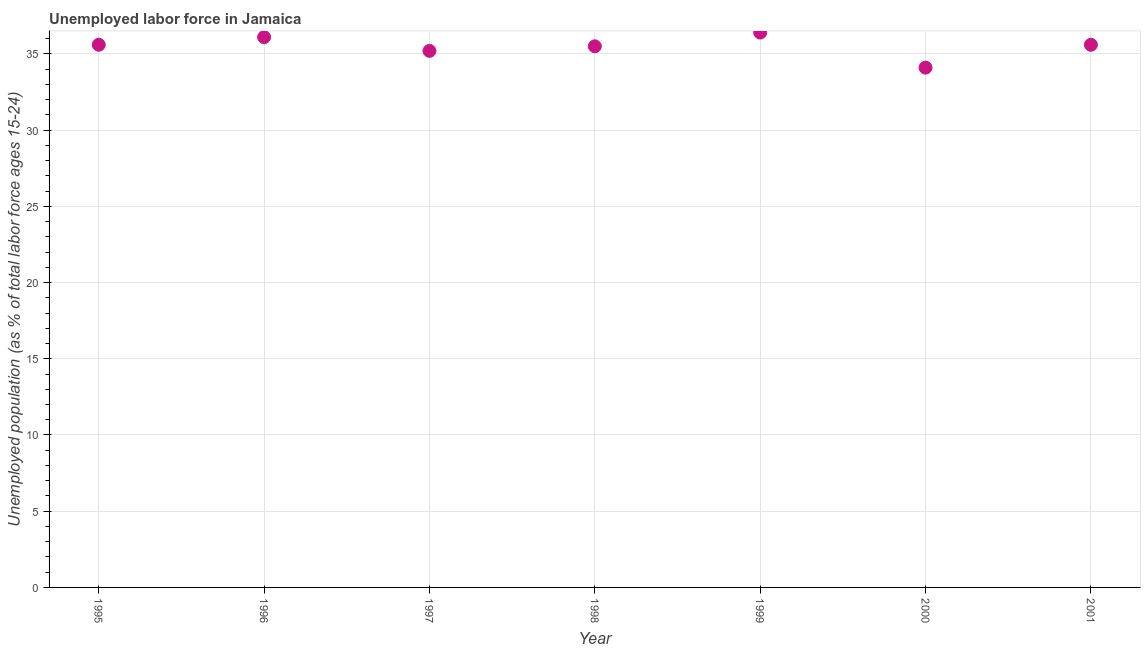What is the total unemployed youth population in 2000?
Your answer should be compact. 34.1. Across all years, what is the maximum total unemployed youth population?
Provide a succinct answer. 36.4. Across all years, what is the minimum total unemployed youth population?
Your answer should be compact. 34.1. In which year was the total unemployed youth population maximum?
Provide a succinct answer. 1999. In which year was the total unemployed youth population minimum?
Your response must be concise. 2000. What is the sum of the total unemployed youth population?
Make the answer very short. 248.5. What is the difference between the total unemployed youth population in 1995 and 2000?
Provide a short and direct response. 1.5. What is the average total unemployed youth population per year?
Provide a short and direct response. 35.5. What is the median total unemployed youth population?
Offer a very short reply. 35.6. What is the ratio of the total unemployed youth population in 2000 to that in 2001?
Give a very brief answer. 0.96. What is the difference between the highest and the second highest total unemployed youth population?
Your response must be concise. 0.3. Is the sum of the total unemployed youth population in 1996 and 2000 greater than the maximum total unemployed youth population across all years?
Ensure brevity in your answer.  Yes. What is the difference between the highest and the lowest total unemployed youth population?
Offer a very short reply. 2.3. Are the values on the major ticks of Y-axis written in scientific E-notation?
Provide a short and direct response. No. Does the graph contain any zero values?
Offer a very short reply. No. What is the title of the graph?
Provide a short and direct response. Unemployed labor force in Jamaica. What is the label or title of the Y-axis?
Your answer should be compact. Unemployed population (as % of total labor force ages 15-24). What is the Unemployed population (as % of total labor force ages 15-24) in 1995?
Provide a succinct answer. 35.6. What is the Unemployed population (as % of total labor force ages 15-24) in 1996?
Ensure brevity in your answer.  36.1. What is the Unemployed population (as % of total labor force ages 15-24) in 1997?
Give a very brief answer. 35.2. What is the Unemployed population (as % of total labor force ages 15-24) in 1998?
Keep it short and to the point. 35.5. What is the Unemployed population (as % of total labor force ages 15-24) in 1999?
Provide a short and direct response. 36.4. What is the Unemployed population (as % of total labor force ages 15-24) in 2000?
Provide a short and direct response. 34.1. What is the Unemployed population (as % of total labor force ages 15-24) in 2001?
Ensure brevity in your answer.  35.6. What is the difference between the Unemployed population (as % of total labor force ages 15-24) in 1995 and 1996?
Your answer should be very brief. -0.5. What is the difference between the Unemployed population (as % of total labor force ages 15-24) in 1995 and 1997?
Offer a very short reply. 0.4. What is the difference between the Unemployed population (as % of total labor force ages 15-24) in 1995 and 1998?
Offer a terse response. 0.1. What is the difference between the Unemployed population (as % of total labor force ages 15-24) in 1995 and 1999?
Keep it short and to the point. -0.8. What is the difference between the Unemployed population (as % of total labor force ages 15-24) in 1995 and 2001?
Give a very brief answer. 0. What is the difference between the Unemployed population (as % of total labor force ages 15-24) in 1996 and 1997?
Ensure brevity in your answer.  0.9. What is the difference between the Unemployed population (as % of total labor force ages 15-24) in 1996 and 1998?
Your response must be concise. 0.6. What is the difference between the Unemployed population (as % of total labor force ages 15-24) in 1996 and 1999?
Make the answer very short. -0.3. What is the difference between the Unemployed population (as % of total labor force ages 15-24) in 1998 and 2000?
Your answer should be very brief. 1.4. What is the difference between the Unemployed population (as % of total labor force ages 15-24) in 2000 and 2001?
Provide a succinct answer. -1.5. What is the ratio of the Unemployed population (as % of total labor force ages 15-24) in 1995 to that in 1996?
Give a very brief answer. 0.99. What is the ratio of the Unemployed population (as % of total labor force ages 15-24) in 1995 to that in 1997?
Make the answer very short. 1.01. What is the ratio of the Unemployed population (as % of total labor force ages 15-24) in 1995 to that in 1998?
Give a very brief answer. 1. What is the ratio of the Unemployed population (as % of total labor force ages 15-24) in 1995 to that in 2000?
Your answer should be compact. 1.04. What is the ratio of the Unemployed population (as % of total labor force ages 15-24) in 1995 to that in 2001?
Your response must be concise. 1. What is the ratio of the Unemployed population (as % of total labor force ages 15-24) in 1996 to that in 1999?
Your answer should be compact. 0.99. What is the ratio of the Unemployed population (as % of total labor force ages 15-24) in 1996 to that in 2000?
Your answer should be compact. 1.06. What is the ratio of the Unemployed population (as % of total labor force ages 15-24) in 1996 to that in 2001?
Offer a very short reply. 1.01. What is the ratio of the Unemployed population (as % of total labor force ages 15-24) in 1997 to that in 1998?
Offer a very short reply. 0.99. What is the ratio of the Unemployed population (as % of total labor force ages 15-24) in 1997 to that in 2000?
Ensure brevity in your answer.  1.03. What is the ratio of the Unemployed population (as % of total labor force ages 15-24) in 1997 to that in 2001?
Give a very brief answer. 0.99. What is the ratio of the Unemployed population (as % of total labor force ages 15-24) in 1998 to that in 1999?
Make the answer very short. 0.97. What is the ratio of the Unemployed population (as % of total labor force ages 15-24) in 1998 to that in 2000?
Make the answer very short. 1.04. What is the ratio of the Unemployed population (as % of total labor force ages 15-24) in 1998 to that in 2001?
Offer a terse response. 1. What is the ratio of the Unemployed population (as % of total labor force ages 15-24) in 1999 to that in 2000?
Your response must be concise. 1.07. What is the ratio of the Unemployed population (as % of total labor force ages 15-24) in 2000 to that in 2001?
Make the answer very short. 0.96. 